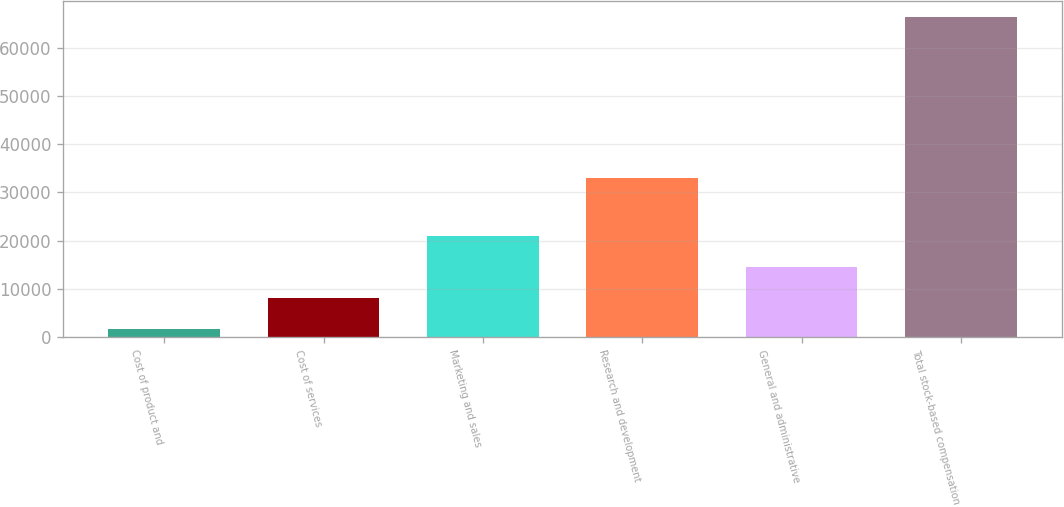<chart> <loc_0><loc_0><loc_500><loc_500><bar_chart><fcel>Cost of product and<fcel>Cost of services<fcel>Marketing and sales<fcel>Research and development<fcel>General and administrative<fcel>Total stock-based compensation<nl><fcel>1596<fcel>8064.9<fcel>21002.7<fcel>32999<fcel>14533.8<fcel>66285<nl></chart> 